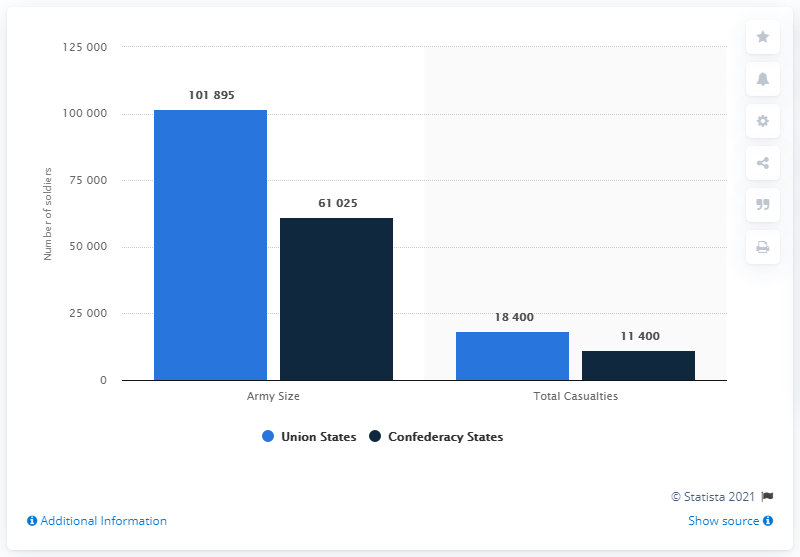Identify some key points in this picture. The total value of all bars is 192,720. The value of the highest bar is 101895. 